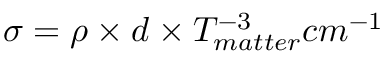Convert formula to latex. <formula><loc_0><loc_0><loc_500><loc_500>\sigma = \rho \times d \times T _ { m a t t e r } ^ { - 3 } c m ^ { - 1 }</formula> 